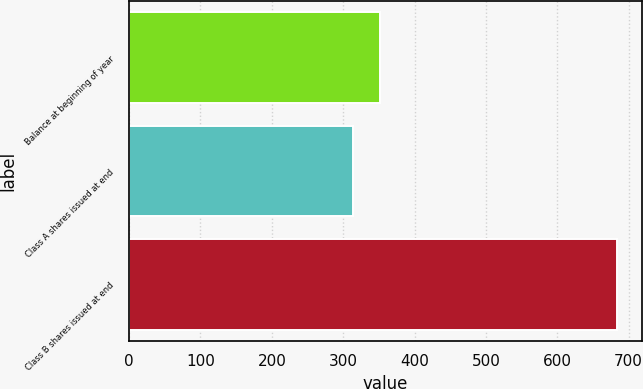Convert chart. <chart><loc_0><loc_0><loc_500><loc_500><bar_chart><fcel>Balance at beginning of year<fcel>Class A shares issued at end<fcel>Class B shares issued at end<nl><fcel>351<fcel>314<fcel>684<nl></chart> 